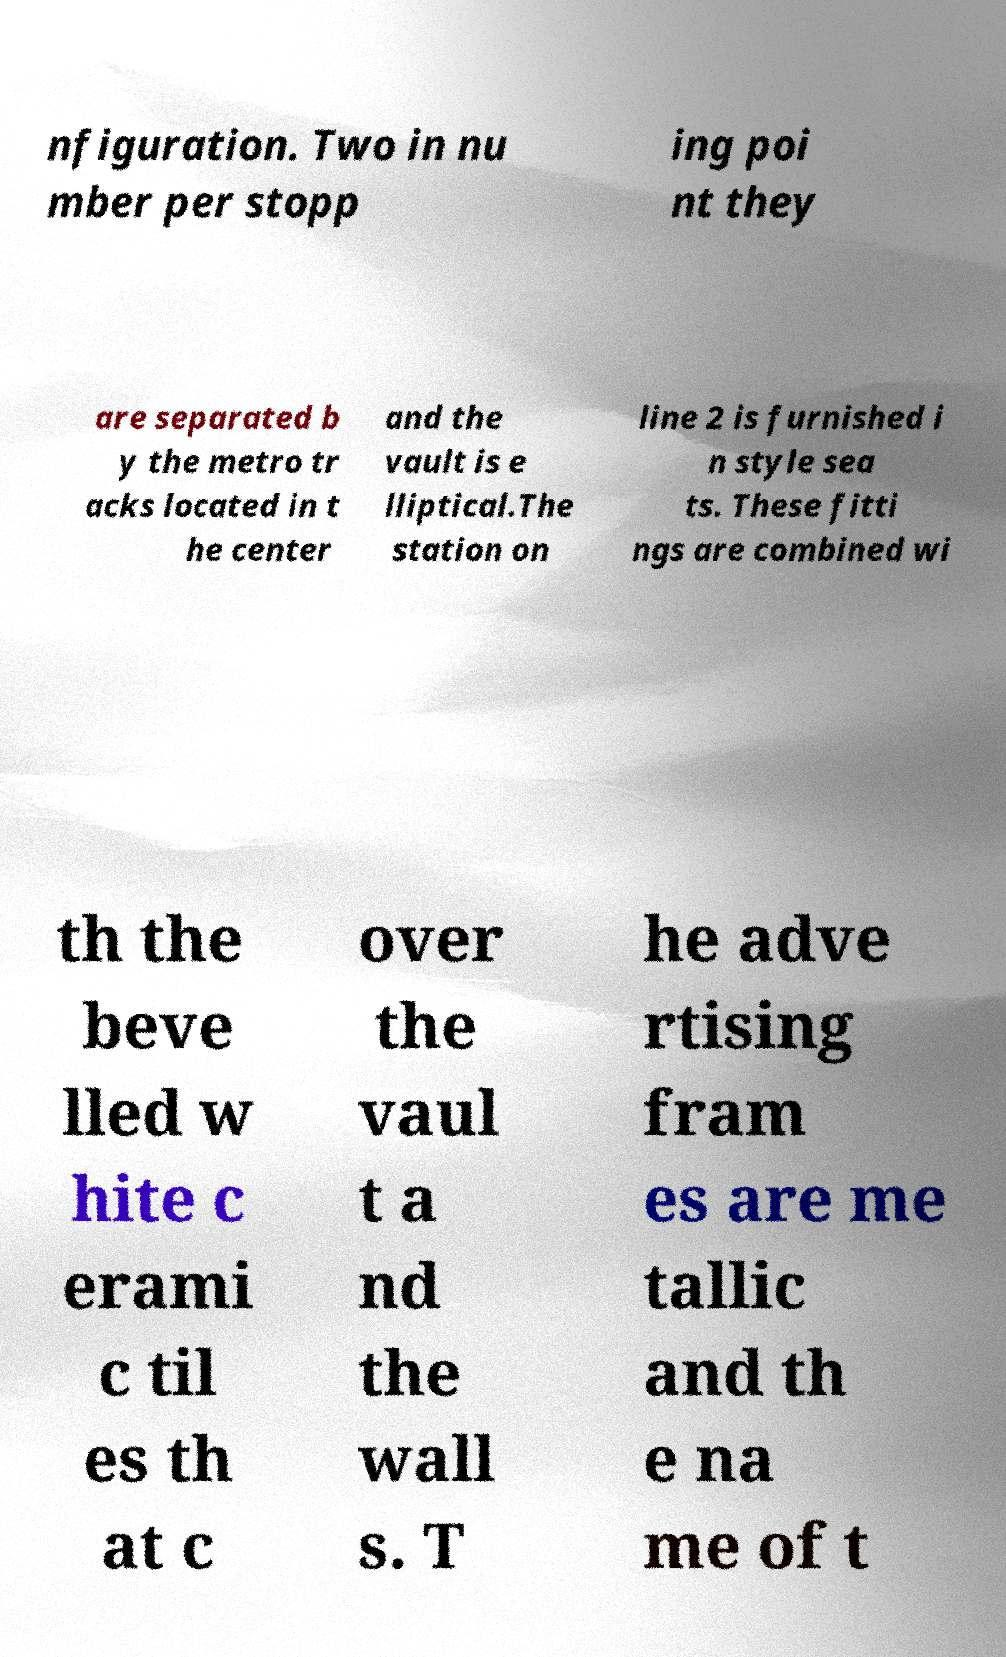Could you extract and type out the text from this image? nfiguration. Two in nu mber per stopp ing poi nt they are separated b y the metro tr acks located in t he center and the vault is e lliptical.The station on line 2 is furnished i n style sea ts. These fitti ngs are combined wi th the beve lled w hite c erami c til es th at c over the vaul t a nd the wall s. T he adve rtising fram es are me tallic and th e na me of t 